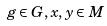Convert formula to latex. <formula><loc_0><loc_0><loc_500><loc_500>g \in G , x , y \in M</formula> 